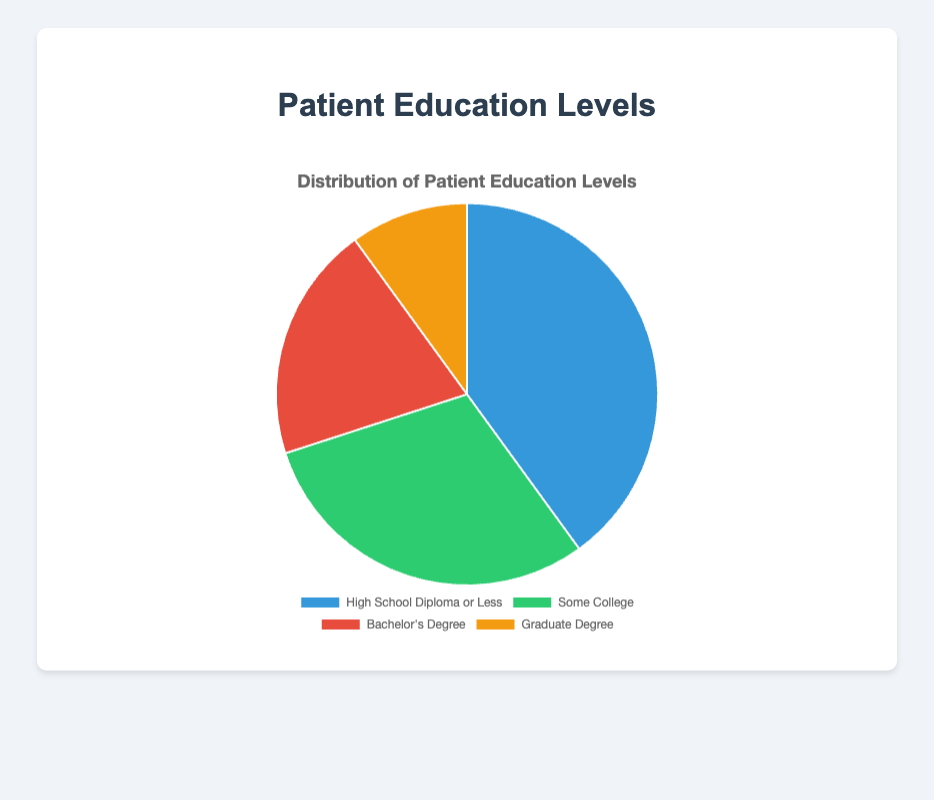What's the percentage of patients with a Bachelor's Degree? The 'Bachelor's Degree' slice in the pie chart represents 20% of the total. This can be directly observed from the chart legend or tooltip.
Answer: 20% Which education level category has the highest percentage of patients? The pie chart shows that 'High School Diploma or Less' has the largest slice, representing 40% of the total. The legend and slice sizes can confirm this.
Answer: High School Diploma or Less How many patients have a Graduate Degree compared to those with Some College? The percentage of patients with a Graduate Degree is 10%, and for Some College is 30%. By comparing these percentages visually, the 'Some College' slice is larger, indicating more patients.
Answer: Some College What is the total percentage of patients with at least a Bachelor's Degree? Sum the percentages of 'Bachelor's Degree' and 'Graduate Degree': 20% + 10% = 30%. This involves adding the two relevant slices together.
Answer: 30% Which color represents the 'Some College' category in the pie chart? The pie chart uses green to represent the 'Some College' category. This can be identified from the chart legend matching the color slice.
Answer: Green Is there a higher percentage of patients with some form of college education (Some College or Bachelor's Degree) compared to those with a High School Diploma or Less? The sum of 'Some College' and 'Bachelor's Degree' patients is 30% + 20% = 50%, while 'High School Diploma or Less' is 40%. By comparing these values, 50% is greater than 40%.
Answer: Yes What percentage difference exists between patients with a High School Diploma or Less and a Graduate Degree? The difference is calculated as 40% - 10% = 30%. This requires subtracting the smaller percentage from the larger one.
Answer: 30% Which education level has the smallest representation in the patient population? The smallest slice in the pie chart corresponds to 'Graduate Degree' with 10%, as indicated by both the slice size and the legend.
Answer: Graduate Degree 